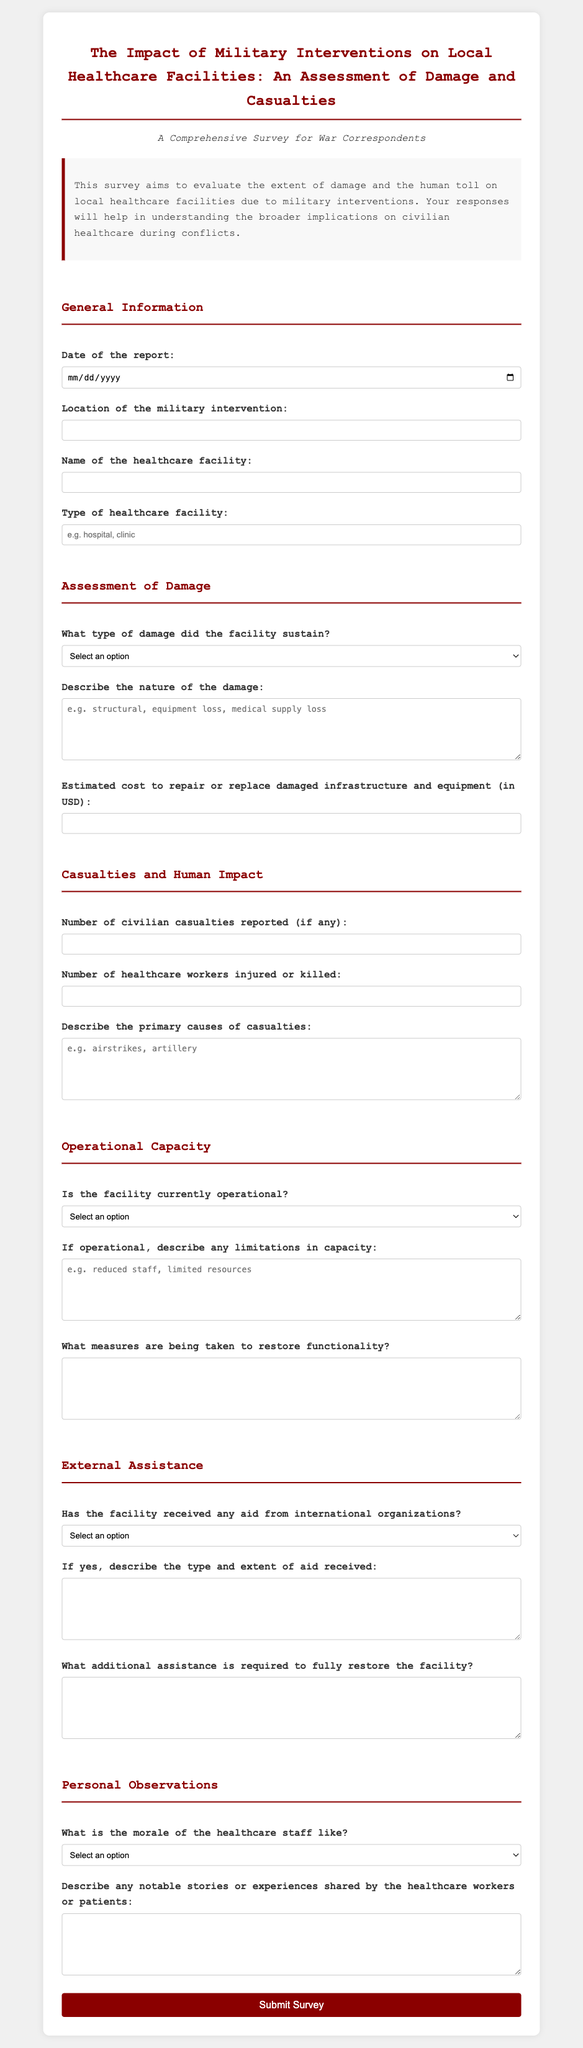What is the title of the survey? The title of the survey is provided in the header of the document.
Answer: The Impact of Military Interventions on Local Healthcare Facilities: An Assessment of Damage and Casualties What is the required information about the date of the report? The document specifies the date of the report as a required field in the general information section.
Answer: Date of the report What are the types of damage that can be reported? The survey includes a dropdown selection for the types of damage that the facility may have sustained, listed in the assessment of damage section.
Answer: Minor Damage, Moderate Damage, Severe Damage, Destroyed How many categories are in the "Casualties and Human Impact" section? The document outlines and lists distinct categories within each section, allowing for a count of the categories under casualties.
Answer: Three What do responders need to describe in the "Additional assistance" field? The specific request for information regarding additional assistance is detailed in the external assistance section of the document.
Answer: What additional assistance is required to fully restore the facility? Is the operational status of the healthcare facility a question in the survey? The survey format includes a question regarding the operational status of the facility, highlighting its relevance to the assessment.
Answer: Yes 